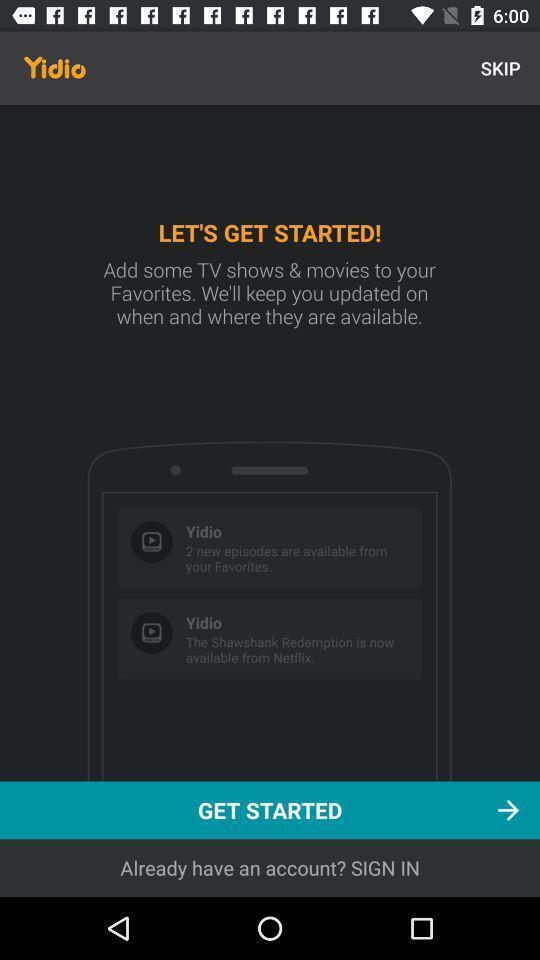Describe the visual elements of this screenshot. Start page. 